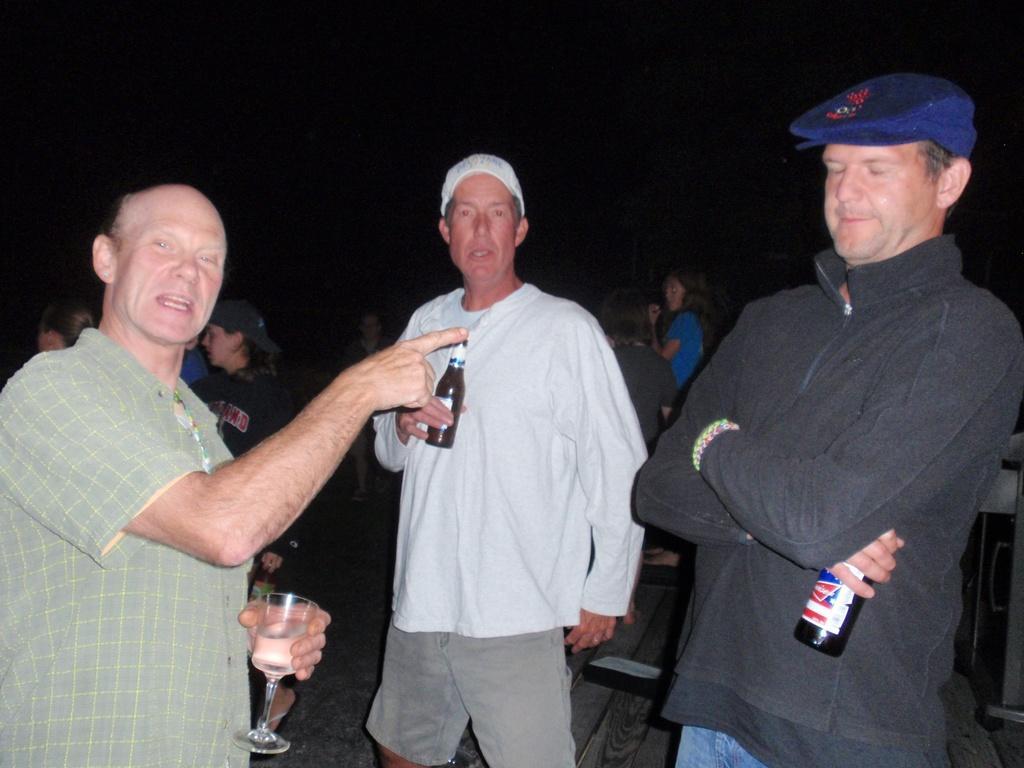In one or two sentences, can you explain what this image depicts? In this image I can see some people are standing. 